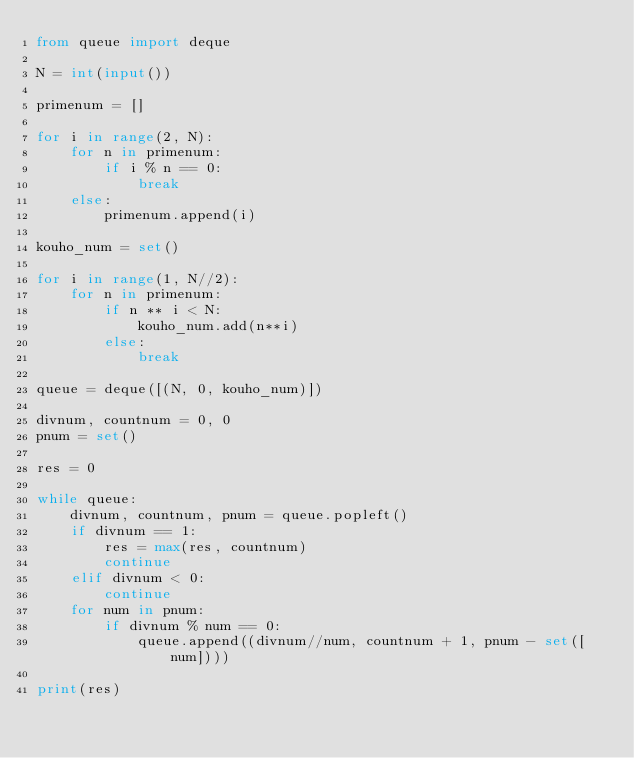Convert code to text. <code><loc_0><loc_0><loc_500><loc_500><_Python_>from queue import deque

N = int(input())

primenum = []

for i in range(2, N):
    for n in primenum:
        if i % n == 0:
            break
    else:
        primenum.append(i)

kouho_num = set()

for i in range(1, N//2):
    for n in primenum:
        if n ** i < N:
            kouho_num.add(n**i)
        else:
            break

queue = deque([(N, 0, kouho_num)])

divnum, countnum = 0, 0
pnum = set()

res = 0

while queue:
    divnum, countnum, pnum = queue.popleft()
    if divnum == 1:
        res = max(res, countnum)
        continue
    elif divnum < 0:
        continue
    for num in pnum:
        if divnum % num == 0:
            queue.append((divnum//num, countnum + 1, pnum - set([num])))

print(res)</code> 